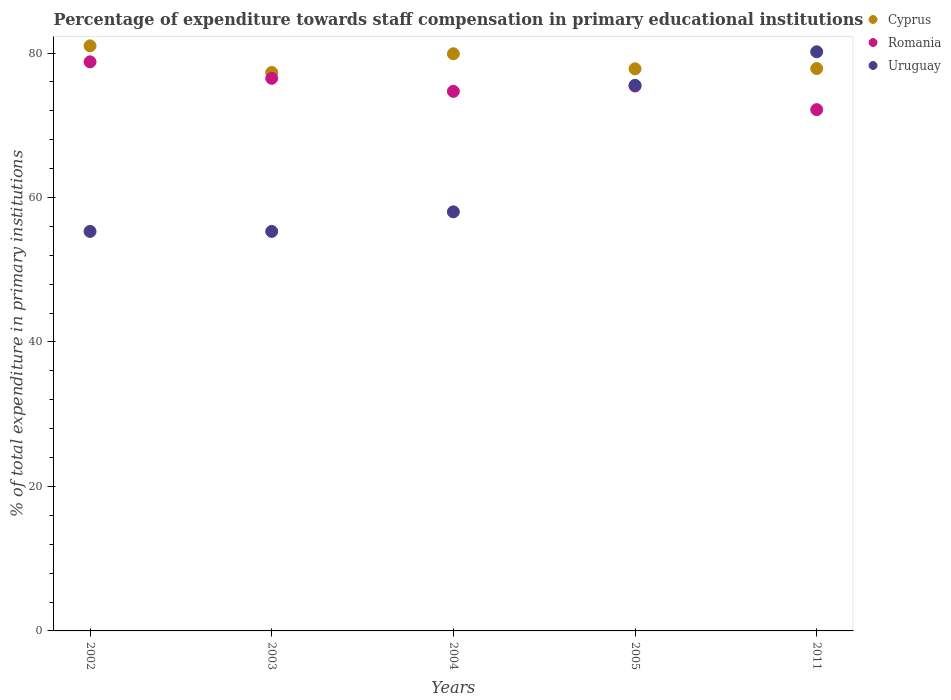What is the percentage of expenditure towards staff compensation in Cyprus in 2011?
Give a very brief answer. 77.85. Across all years, what is the maximum percentage of expenditure towards staff compensation in Romania?
Your answer should be compact. 78.78. Across all years, what is the minimum percentage of expenditure towards staff compensation in Romania?
Provide a short and direct response. 72.16. In which year was the percentage of expenditure towards staff compensation in Cyprus minimum?
Ensure brevity in your answer.  2003. What is the total percentage of expenditure towards staff compensation in Romania in the graph?
Provide a succinct answer. 377.56. What is the difference between the percentage of expenditure towards staff compensation in Cyprus in 2002 and that in 2005?
Provide a succinct answer. 3.18. What is the difference between the percentage of expenditure towards staff compensation in Romania in 2011 and the percentage of expenditure towards staff compensation in Uruguay in 2002?
Keep it short and to the point. 16.86. What is the average percentage of expenditure towards staff compensation in Cyprus per year?
Offer a very short reply. 78.77. In the year 2003, what is the difference between the percentage of expenditure towards staff compensation in Romania and percentage of expenditure towards staff compensation in Uruguay?
Your answer should be very brief. 21.19. In how many years, is the percentage of expenditure towards staff compensation in Cyprus greater than 72 %?
Give a very brief answer. 5. What is the ratio of the percentage of expenditure towards staff compensation in Romania in 2003 to that in 2005?
Your answer should be very brief. 1.01. Is the percentage of expenditure towards staff compensation in Uruguay in 2003 less than that in 2011?
Make the answer very short. Yes. Is the difference between the percentage of expenditure towards staff compensation in Romania in 2002 and 2004 greater than the difference between the percentage of expenditure towards staff compensation in Uruguay in 2002 and 2004?
Provide a succinct answer. Yes. What is the difference between the highest and the second highest percentage of expenditure towards staff compensation in Uruguay?
Provide a short and direct response. 4.64. What is the difference between the highest and the lowest percentage of expenditure towards staff compensation in Romania?
Make the answer very short. 6.61. In how many years, is the percentage of expenditure towards staff compensation in Cyprus greater than the average percentage of expenditure towards staff compensation in Cyprus taken over all years?
Offer a terse response. 2. Is the sum of the percentage of expenditure towards staff compensation in Cyprus in 2003 and 2004 greater than the maximum percentage of expenditure towards staff compensation in Uruguay across all years?
Make the answer very short. Yes. Is it the case that in every year, the sum of the percentage of expenditure towards staff compensation in Romania and percentage of expenditure towards staff compensation in Uruguay  is greater than the percentage of expenditure towards staff compensation in Cyprus?
Your answer should be very brief. Yes. Does the percentage of expenditure towards staff compensation in Uruguay monotonically increase over the years?
Make the answer very short. Yes. Is the percentage of expenditure towards staff compensation in Cyprus strictly greater than the percentage of expenditure towards staff compensation in Romania over the years?
Offer a very short reply. Yes. How many dotlines are there?
Keep it short and to the point. 3. How many years are there in the graph?
Provide a succinct answer. 5. Are the values on the major ticks of Y-axis written in scientific E-notation?
Offer a very short reply. No. Does the graph contain any zero values?
Your answer should be very brief. No. Does the graph contain grids?
Your answer should be compact. No. Where does the legend appear in the graph?
Provide a succinct answer. Top right. How many legend labels are there?
Ensure brevity in your answer.  3. How are the legend labels stacked?
Your response must be concise. Vertical. What is the title of the graph?
Provide a short and direct response. Percentage of expenditure towards staff compensation in primary educational institutions. What is the label or title of the X-axis?
Keep it short and to the point. Years. What is the label or title of the Y-axis?
Your response must be concise. % of total expenditure in primary institutions. What is the % of total expenditure in primary institutions in Cyprus in 2002?
Give a very brief answer. 80.99. What is the % of total expenditure in primary institutions in Romania in 2002?
Make the answer very short. 78.78. What is the % of total expenditure in primary institutions of Uruguay in 2002?
Keep it short and to the point. 55.3. What is the % of total expenditure in primary institutions of Cyprus in 2003?
Your answer should be very brief. 77.3. What is the % of total expenditure in primary institutions in Romania in 2003?
Keep it short and to the point. 76.5. What is the % of total expenditure in primary institutions of Uruguay in 2003?
Give a very brief answer. 55.31. What is the % of total expenditure in primary institutions of Cyprus in 2004?
Your answer should be very brief. 79.89. What is the % of total expenditure in primary institutions in Romania in 2004?
Give a very brief answer. 74.69. What is the % of total expenditure in primary institutions of Uruguay in 2004?
Your answer should be compact. 58.01. What is the % of total expenditure in primary institutions in Cyprus in 2005?
Make the answer very short. 77.81. What is the % of total expenditure in primary institutions of Romania in 2005?
Give a very brief answer. 75.43. What is the % of total expenditure in primary institutions of Uruguay in 2005?
Provide a succinct answer. 75.53. What is the % of total expenditure in primary institutions of Cyprus in 2011?
Ensure brevity in your answer.  77.85. What is the % of total expenditure in primary institutions in Romania in 2011?
Provide a short and direct response. 72.16. What is the % of total expenditure in primary institutions of Uruguay in 2011?
Your answer should be very brief. 80.17. Across all years, what is the maximum % of total expenditure in primary institutions in Cyprus?
Your response must be concise. 80.99. Across all years, what is the maximum % of total expenditure in primary institutions in Romania?
Make the answer very short. 78.78. Across all years, what is the maximum % of total expenditure in primary institutions of Uruguay?
Make the answer very short. 80.17. Across all years, what is the minimum % of total expenditure in primary institutions of Cyprus?
Your response must be concise. 77.3. Across all years, what is the minimum % of total expenditure in primary institutions of Romania?
Offer a terse response. 72.16. Across all years, what is the minimum % of total expenditure in primary institutions in Uruguay?
Keep it short and to the point. 55.3. What is the total % of total expenditure in primary institutions in Cyprus in the graph?
Offer a terse response. 393.85. What is the total % of total expenditure in primary institutions in Romania in the graph?
Provide a short and direct response. 377.56. What is the total % of total expenditure in primary institutions of Uruguay in the graph?
Offer a terse response. 324.32. What is the difference between the % of total expenditure in primary institutions in Cyprus in 2002 and that in 2003?
Keep it short and to the point. 3.69. What is the difference between the % of total expenditure in primary institutions of Romania in 2002 and that in 2003?
Provide a succinct answer. 2.28. What is the difference between the % of total expenditure in primary institutions of Uruguay in 2002 and that in 2003?
Provide a succinct answer. -0. What is the difference between the % of total expenditure in primary institutions in Cyprus in 2002 and that in 2004?
Provide a short and direct response. 1.1. What is the difference between the % of total expenditure in primary institutions of Romania in 2002 and that in 2004?
Your answer should be compact. 4.09. What is the difference between the % of total expenditure in primary institutions in Uruguay in 2002 and that in 2004?
Give a very brief answer. -2.71. What is the difference between the % of total expenditure in primary institutions in Cyprus in 2002 and that in 2005?
Ensure brevity in your answer.  3.18. What is the difference between the % of total expenditure in primary institutions of Romania in 2002 and that in 2005?
Ensure brevity in your answer.  3.35. What is the difference between the % of total expenditure in primary institutions in Uruguay in 2002 and that in 2005?
Provide a succinct answer. -20.22. What is the difference between the % of total expenditure in primary institutions in Cyprus in 2002 and that in 2011?
Provide a short and direct response. 3.14. What is the difference between the % of total expenditure in primary institutions in Romania in 2002 and that in 2011?
Your response must be concise. 6.61. What is the difference between the % of total expenditure in primary institutions of Uruguay in 2002 and that in 2011?
Your answer should be compact. -24.87. What is the difference between the % of total expenditure in primary institutions in Cyprus in 2003 and that in 2004?
Keep it short and to the point. -2.59. What is the difference between the % of total expenditure in primary institutions in Romania in 2003 and that in 2004?
Give a very brief answer. 1.81. What is the difference between the % of total expenditure in primary institutions of Uruguay in 2003 and that in 2004?
Your response must be concise. -2.71. What is the difference between the % of total expenditure in primary institutions in Cyprus in 2003 and that in 2005?
Provide a short and direct response. -0.51. What is the difference between the % of total expenditure in primary institutions in Romania in 2003 and that in 2005?
Give a very brief answer. 1.07. What is the difference between the % of total expenditure in primary institutions of Uruguay in 2003 and that in 2005?
Offer a terse response. -20.22. What is the difference between the % of total expenditure in primary institutions of Cyprus in 2003 and that in 2011?
Offer a terse response. -0.55. What is the difference between the % of total expenditure in primary institutions in Romania in 2003 and that in 2011?
Give a very brief answer. 4.33. What is the difference between the % of total expenditure in primary institutions of Uruguay in 2003 and that in 2011?
Keep it short and to the point. -24.86. What is the difference between the % of total expenditure in primary institutions in Cyprus in 2004 and that in 2005?
Provide a succinct answer. 2.08. What is the difference between the % of total expenditure in primary institutions in Romania in 2004 and that in 2005?
Give a very brief answer. -0.74. What is the difference between the % of total expenditure in primary institutions in Uruguay in 2004 and that in 2005?
Provide a short and direct response. -17.52. What is the difference between the % of total expenditure in primary institutions of Cyprus in 2004 and that in 2011?
Offer a terse response. 2.04. What is the difference between the % of total expenditure in primary institutions of Romania in 2004 and that in 2011?
Offer a terse response. 2.53. What is the difference between the % of total expenditure in primary institutions of Uruguay in 2004 and that in 2011?
Offer a terse response. -22.16. What is the difference between the % of total expenditure in primary institutions of Cyprus in 2005 and that in 2011?
Make the answer very short. -0.04. What is the difference between the % of total expenditure in primary institutions of Romania in 2005 and that in 2011?
Offer a terse response. 3.27. What is the difference between the % of total expenditure in primary institutions of Uruguay in 2005 and that in 2011?
Give a very brief answer. -4.64. What is the difference between the % of total expenditure in primary institutions in Cyprus in 2002 and the % of total expenditure in primary institutions in Romania in 2003?
Your response must be concise. 4.49. What is the difference between the % of total expenditure in primary institutions of Cyprus in 2002 and the % of total expenditure in primary institutions of Uruguay in 2003?
Offer a very short reply. 25.69. What is the difference between the % of total expenditure in primary institutions of Romania in 2002 and the % of total expenditure in primary institutions of Uruguay in 2003?
Your answer should be compact. 23.47. What is the difference between the % of total expenditure in primary institutions of Cyprus in 2002 and the % of total expenditure in primary institutions of Romania in 2004?
Provide a short and direct response. 6.3. What is the difference between the % of total expenditure in primary institutions of Cyprus in 2002 and the % of total expenditure in primary institutions of Uruguay in 2004?
Offer a terse response. 22.98. What is the difference between the % of total expenditure in primary institutions in Romania in 2002 and the % of total expenditure in primary institutions in Uruguay in 2004?
Give a very brief answer. 20.77. What is the difference between the % of total expenditure in primary institutions of Cyprus in 2002 and the % of total expenditure in primary institutions of Romania in 2005?
Offer a very short reply. 5.56. What is the difference between the % of total expenditure in primary institutions in Cyprus in 2002 and the % of total expenditure in primary institutions in Uruguay in 2005?
Keep it short and to the point. 5.46. What is the difference between the % of total expenditure in primary institutions in Romania in 2002 and the % of total expenditure in primary institutions in Uruguay in 2005?
Your response must be concise. 3.25. What is the difference between the % of total expenditure in primary institutions of Cyprus in 2002 and the % of total expenditure in primary institutions of Romania in 2011?
Your answer should be compact. 8.83. What is the difference between the % of total expenditure in primary institutions in Cyprus in 2002 and the % of total expenditure in primary institutions in Uruguay in 2011?
Offer a very short reply. 0.82. What is the difference between the % of total expenditure in primary institutions in Romania in 2002 and the % of total expenditure in primary institutions in Uruguay in 2011?
Your answer should be very brief. -1.39. What is the difference between the % of total expenditure in primary institutions in Cyprus in 2003 and the % of total expenditure in primary institutions in Romania in 2004?
Ensure brevity in your answer.  2.61. What is the difference between the % of total expenditure in primary institutions in Cyprus in 2003 and the % of total expenditure in primary institutions in Uruguay in 2004?
Provide a short and direct response. 19.29. What is the difference between the % of total expenditure in primary institutions in Romania in 2003 and the % of total expenditure in primary institutions in Uruguay in 2004?
Give a very brief answer. 18.49. What is the difference between the % of total expenditure in primary institutions of Cyprus in 2003 and the % of total expenditure in primary institutions of Romania in 2005?
Your response must be concise. 1.88. What is the difference between the % of total expenditure in primary institutions of Cyprus in 2003 and the % of total expenditure in primary institutions of Uruguay in 2005?
Your answer should be very brief. 1.78. What is the difference between the % of total expenditure in primary institutions in Romania in 2003 and the % of total expenditure in primary institutions in Uruguay in 2005?
Provide a succinct answer. 0.97. What is the difference between the % of total expenditure in primary institutions of Cyprus in 2003 and the % of total expenditure in primary institutions of Romania in 2011?
Offer a terse response. 5.14. What is the difference between the % of total expenditure in primary institutions of Cyprus in 2003 and the % of total expenditure in primary institutions of Uruguay in 2011?
Offer a very short reply. -2.87. What is the difference between the % of total expenditure in primary institutions in Romania in 2003 and the % of total expenditure in primary institutions in Uruguay in 2011?
Your answer should be very brief. -3.67. What is the difference between the % of total expenditure in primary institutions of Cyprus in 2004 and the % of total expenditure in primary institutions of Romania in 2005?
Provide a succinct answer. 4.47. What is the difference between the % of total expenditure in primary institutions in Cyprus in 2004 and the % of total expenditure in primary institutions in Uruguay in 2005?
Your answer should be very brief. 4.37. What is the difference between the % of total expenditure in primary institutions of Romania in 2004 and the % of total expenditure in primary institutions of Uruguay in 2005?
Offer a very short reply. -0.84. What is the difference between the % of total expenditure in primary institutions in Cyprus in 2004 and the % of total expenditure in primary institutions in Romania in 2011?
Your response must be concise. 7.73. What is the difference between the % of total expenditure in primary institutions in Cyprus in 2004 and the % of total expenditure in primary institutions in Uruguay in 2011?
Make the answer very short. -0.28. What is the difference between the % of total expenditure in primary institutions in Romania in 2004 and the % of total expenditure in primary institutions in Uruguay in 2011?
Give a very brief answer. -5.48. What is the difference between the % of total expenditure in primary institutions in Cyprus in 2005 and the % of total expenditure in primary institutions in Romania in 2011?
Keep it short and to the point. 5.65. What is the difference between the % of total expenditure in primary institutions in Cyprus in 2005 and the % of total expenditure in primary institutions in Uruguay in 2011?
Provide a short and direct response. -2.36. What is the difference between the % of total expenditure in primary institutions in Romania in 2005 and the % of total expenditure in primary institutions in Uruguay in 2011?
Offer a very short reply. -4.74. What is the average % of total expenditure in primary institutions in Cyprus per year?
Offer a very short reply. 78.77. What is the average % of total expenditure in primary institutions in Romania per year?
Your response must be concise. 75.51. What is the average % of total expenditure in primary institutions of Uruguay per year?
Keep it short and to the point. 64.86. In the year 2002, what is the difference between the % of total expenditure in primary institutions of Cyprus and % of total expenditure in primary institutions of Romania?
Provide a short and direct response. 2.21. In the year 2002, what is the difference between the % of total expenditure in primary institutions of Cyprus and % of total expenditure in primary institutions of Uruguay?
Your answer should be compact. 25.69. In the year 2002, what is the difference between the % of total expenditure in primary institutions of Romania and % of total expenditure in primary institutions of Uruguay?
Your answer should be very brief. 23.47. In the year 2003, what is the difference between the % of total expenditure in primary institutions of Cyprus and % of total expenditure in primary institutions of Romania?
Offer a terse response. 0.81. In the year 2003, what is the difference between the % of total expenditure in primary institutions in Cyprus and % of total expenditure in primary institutions in Uruguay?
Provide a succinct answer. 22. In the year 2003, what is the difference between the % of total expenditure in primary institutions in Romania and % of total expenditure in primary institutions in Uruguay?
Offer a terse response. 21.19. In the year 2004, what is the difference between the % of total expenditure in primary institutions in Cyprus and % of total expenditure in primary institutions in Romania?
Provide a short and direct response. 5.2. In the year 2004, what is the difference between the % of total expenditure in primary institutions of Cyprus and % of total expenditure in primary institutions of Uruguay?
Your answer should be compact. 21.88. In the year 2004, what is the difference between the % of total expenditure in primary institutions in Romania and % of total expenditure in primary institutions in Uruguay?
Your response must be concise. 16.68. In the year 2005, what is the difference between the % of total expenditure in primary institutions in Cyprus and % of total expenditure in primary institutions in Romania?
Ensure brevity in your answer.  2.38. In the year 2005, what is the difference between the % of total expenditure in primary institutions in Cyprus and % of total expenditure in primary institutions in Uruguay?
Give a very brief answer. 2.29. In the year 2005, what is the difference between the % of total expenditure in primary institutions of Romania and % of total expenditure in primary institutions of Uruguay?
Ensure brevity in your answer.  -0.1. In the year 2011, what is the difference between the % of total expenditure in primary institutions in Cyprus and % of total expenditure in primary institutions in Romania?
Offer a very short reply. 5.69. In the year 2011, what is the difference between the % of total expenditure in primary institutions of Cyprus and % of total expenditure in primary institutions of Uruguay?
Keep it short and to the point. -2.32. In the year 2011, what is the difference between the % of total expenditure in primary institutions of Romania and % of total expenditure in primary institutions of Uruguay?
Ensure brevity in your answer.  -8.01. What is the ratio of the % of total expenditure in primary institutions in Cyprus in 2002 to that in 2003?
Your answer should be very brief. 1.05. What is the ratio of the % of total expenditure in primary institutions in Romania in 2002 to that in 2003?
Your answer should be very brief. 1.03. What is the ratio of the % of total expenditure in primary institutions of Cyprus in 2002 to that in 2004?
Your answer should be very brief. 1.01. What is the ratio of the % of total expenditure in primary institutions of Romania in 2002 to that in 2004?
Your answer should be very brief. 1.05. What is the ratio of the % of total expenditure in primary institutions of Uruguay in 2002 to that in 2004?
Offer a very short reply. 0.95. What is the ratio of the % of total expenditure in primary institutions in Cyprus in 2002 to that in 2005?
Offer a terse response. 1.04. What is the ratio of the % of total expenditure in primary institutions in Romania in 2002 to that in 2005?
Give a very brief answer. 1.04. What is the ratio of the % of total expenditure in primary institutions of Uruguay in 2002 to that in 2005?
Provide a short and direct response. 0.73. What is the ratio of the % of total expenditure in primary institutions of Cyprus in 2002 to that in 2011?
Your response must be concise. 1.04. What is the ratio of the % of total expenditure in primary institutions in Romania in 2002 to that in 2011?
Make the answer very short. 1.09. What is the ratio of the % of total expenditure in primary institutions in Uruguay in 2002 to that in 2011?
Keep it short and to the point. 0.69. What is the ratio of the % of total expenditure in primary institutions in Cyprus in 2003 to that in 2004?
Give a very brief answer. 0.97. What is the ratio of the % of total expenditure in primary institutions of Romania in 2003 to that in 2004?
Make the answer very short. 1.02. What is the ratio of the % of total expenditure in primary institutions in Uruguay in 2003 to that in 2004?
Your answer should be very brief. 0.95. What is the ratio of the % of total expenditure in primary institutions in Romania in 2003 to that in 2005?
Give a very brief answer. 1.01. What is the ratio of the % of total expenditure in primary institutions of Uruguay in 2003 to that in 2005?
Keep it short and to the point. 0.73. What is the ratio of the % of total expenditure in primary institutions of Cyprus in 2003 to that in 2011?
Your answer should be compact. 0.99. What is the ratio of the % of total expenditure in primary institutions in Romania in 2003 to that in 2011?
Make the answer very short. 1.06. What is the ratio of the % of total expenditure in primary institutions in Uruguay in 2003 to that in 2011?
Your response must be concise. 0.69. What is the ratio of the % of total expenditure in primary institutions of Cyprus in 2004 to that in 2005?
Ensure brevity in your answer.  1.03. What is the ratio of the % of total expenditure in primary institutions of Romania in 2004 to that in 2005?
Give a very brief answer. 0.99. What is the ratio of the % of total expenditure in primary institutions of Uruguay in 2004 to that in 2005?
Your answer should be compact. 0.77. What is the ratio of the % of total expenditure in primary institutions in Cyprus in 2004 to that in 2011?
Make the answer very short. 1.03. What is the ratio of the % of total expenditure in primary institutions in Romania in 2004 to that in 2011?
Keep it short and to the point. 1.03. What is the ratio of the % of total expenditure in primary institutions of Uruguay in 2004 to that in 2011?
Offer a terse response. 0.72. What is the ratio of the % of total expenditure in primary institutions in Romania in 2005 to that in 2011?
Offer a terse response. 1.05. What is the ratio of the % of total expenditure in primary institutions of Uruguay in 2005 to that in 2011?
Offer a terse response. 0.94. What is the difference between the highest and the second highest % of total expenditure in primary institutions in Cyprus?
Your answer should be very brief. 1.1. What is the difference between the highest and the second highest % of total expenditure in primary institutions in Romania?
Your response must be concise. 2.28. What is the difference between the highest and the second highest % of total expenditure in primary institutions in Uruguay?
Your answer should be very brief. 4.64. What is the difference between the highest and the lowest % of total expenditure in primary institutions in Cyprus?
Your answer should be compact. 3.69. What is the difference between the highest and the lowest % of total expenditure in primary institutions in Romania?
Give a very brief answer. 6.61. What is the difference between the highest and the lowest % of total expenditure in primary institutions of Uruguay?
Offer a terse response. 24.87. 